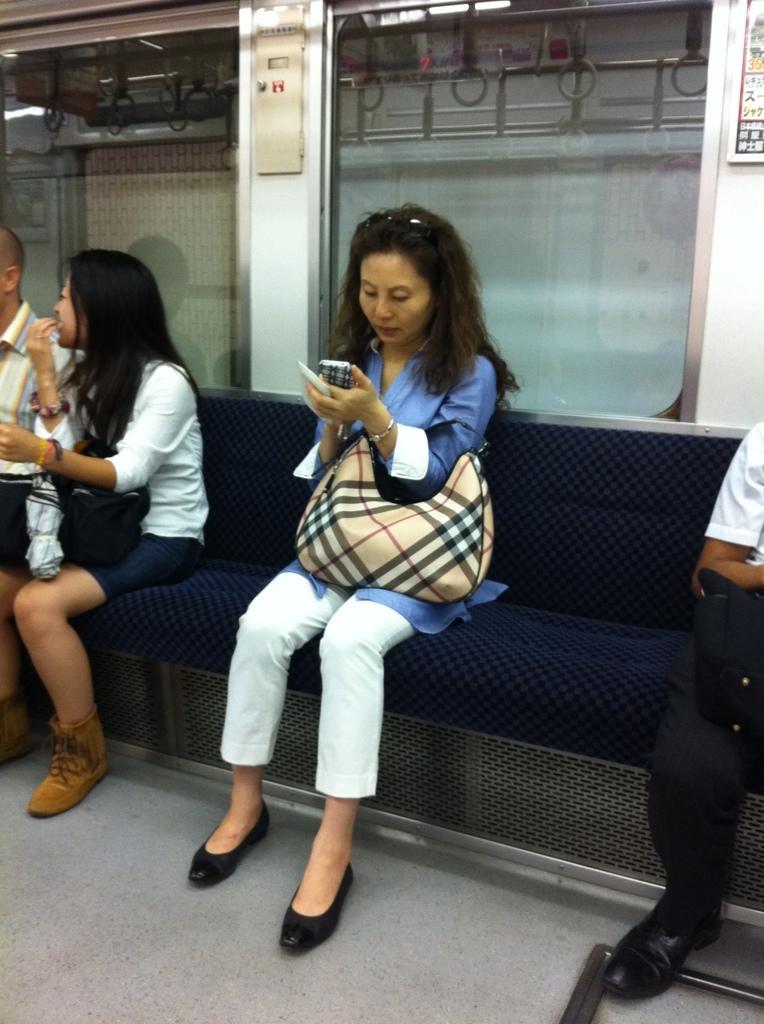Describe this image in one or two sentences. In this picture we can see an inside of a vehicle, here we can see people sitting on a seat. 